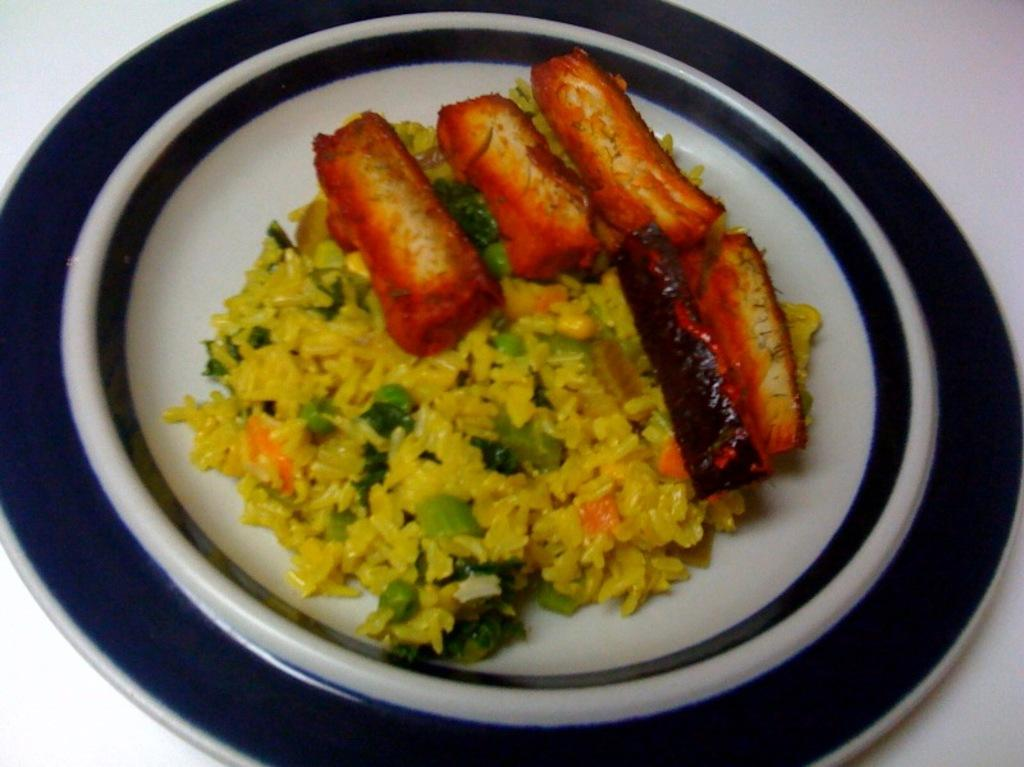What is present in the image related to food? There are food items in the image. How are the food items arranged or contained? The food items are in a plate. Where is the plate with food items located? The plate is on a platform. What is the purpose of the ice in the image? There is no ice present in the image, so it is not possible to determine its purpose. 